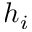<formula> <loc_0><loc_0><loc_500><loc_500>h _ { i }</formula> 